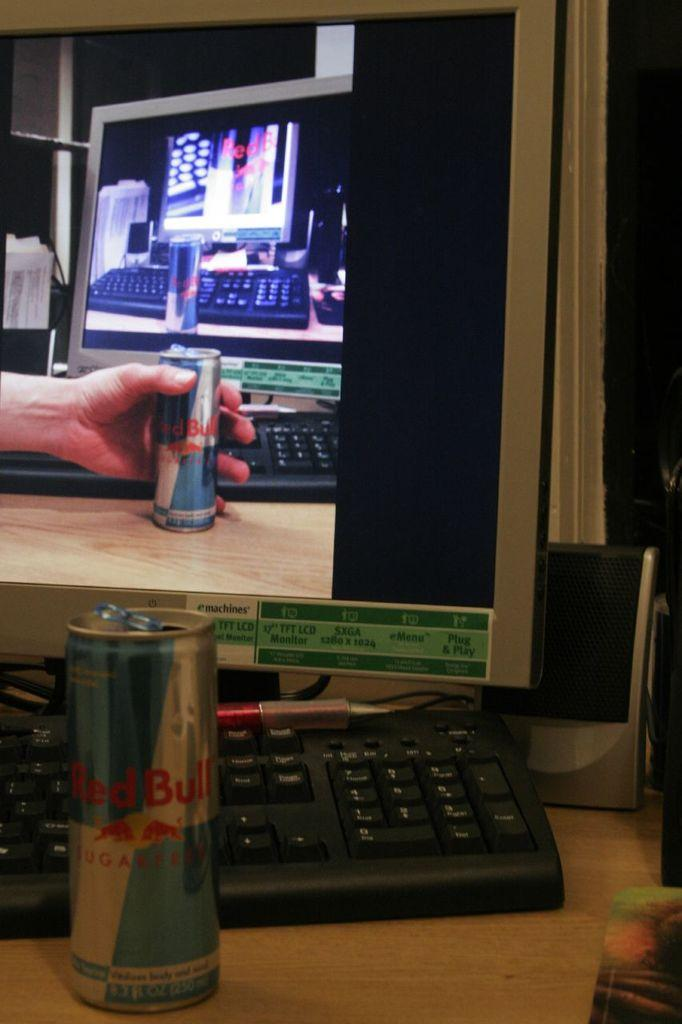What type of animal is in the image? There is a red bull in the image. What electronic device is present in the image? There is a monitor in the image. Where are the red bull and the monitor located? Both objects are on a table. What is the name of the red bull in the image? There is no specific name given for the red bull in the image. How many eggs are visible in the image? There are no eggs present in the image. What type of drug is being used by the red bull in the image? There is no drug use depicted in the image; it features a red bull and a monitor on a table. 